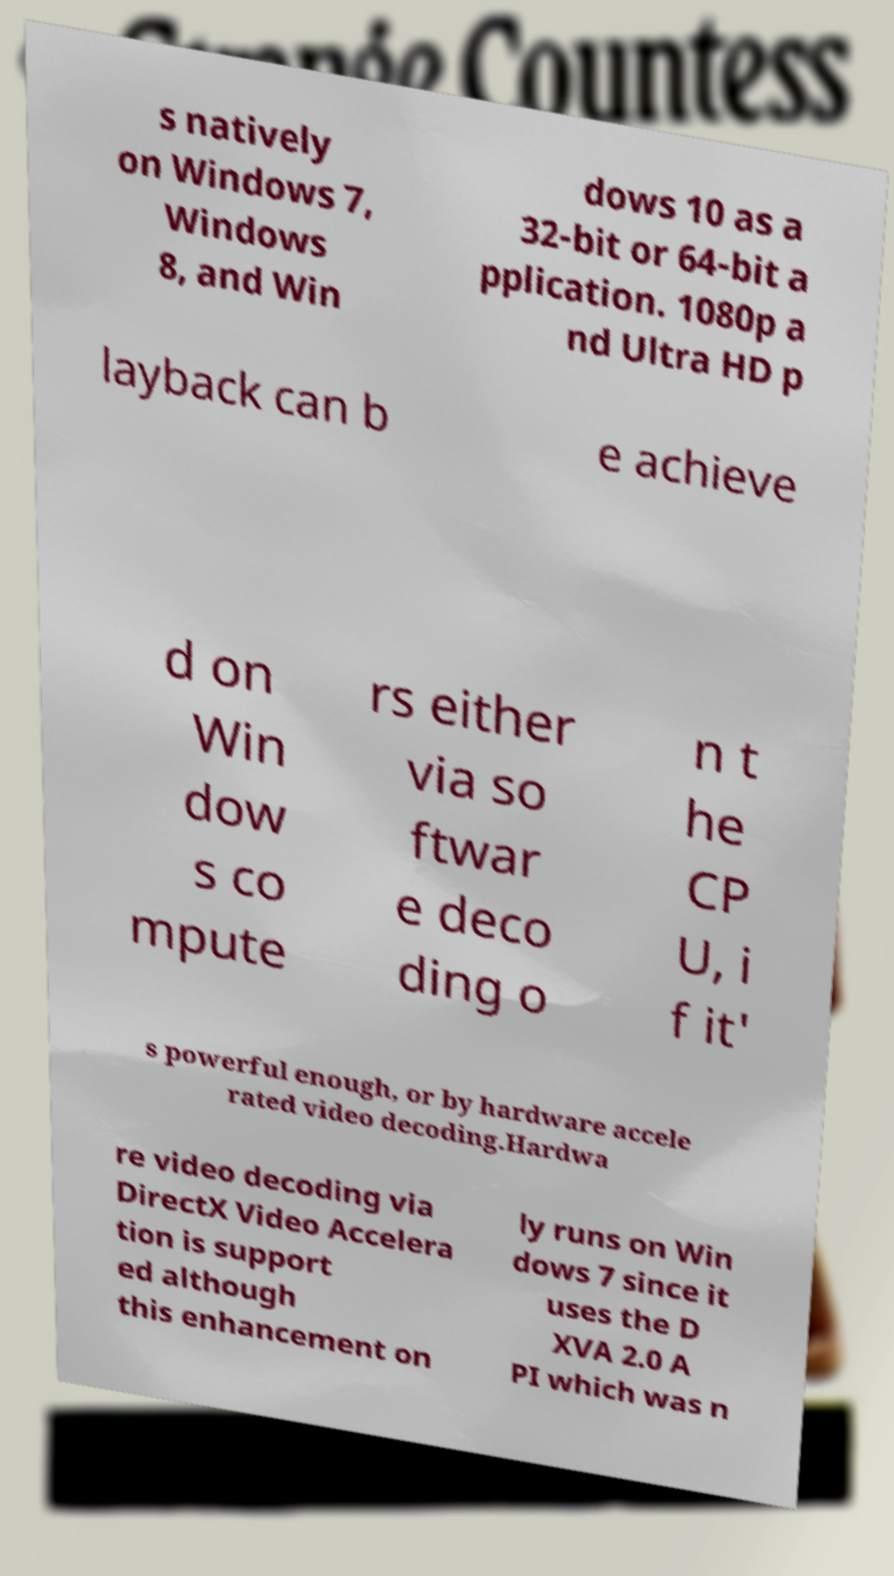For documentation purposes, I need the text within this image transcribed. Could you provide that? s natively on Windows 7, Windows 8, and Win dows 10 as a 32-bit or 64-bit a pplication. 1080p a nd Ultra HD p layback can b e achieve d on Win dow s co mpute rs either via so ftwar e deco ding o n t he CP U, i f it' s powerful enough, or by hardware accele rated video decoding.Hardwa re video decoding via DirectX Video Accelera tion is support ed although this enhancement on ly runs on Win dows 7 since it uses the D XVA 2.0 A PI which was n 